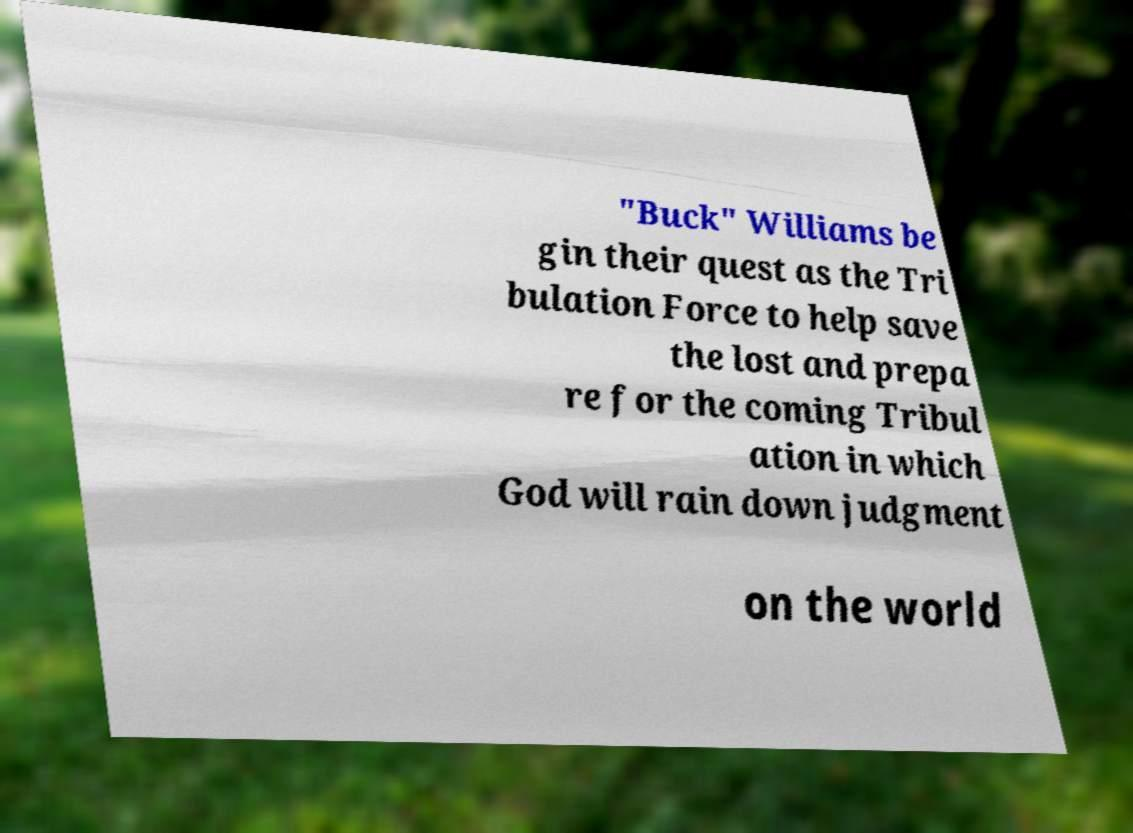What messages or text are displayed in this image? I need them in a readable, typed format. "Buck" Williams be gin their quest as the Tri bulation Force to help save the lost and prepa re for the coming Tribul ation in which God will rain down judgment on the world 